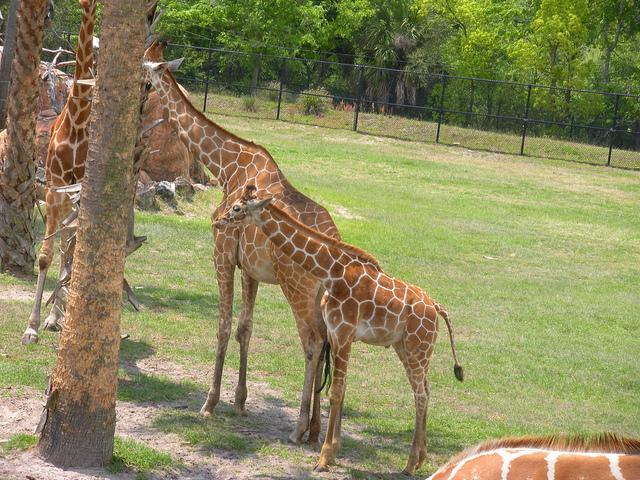Why are the animals enclosed in one area? Please explain your reasoning. to protect. These animals are fenced in so as to protect them from the wild so as to be on display. 